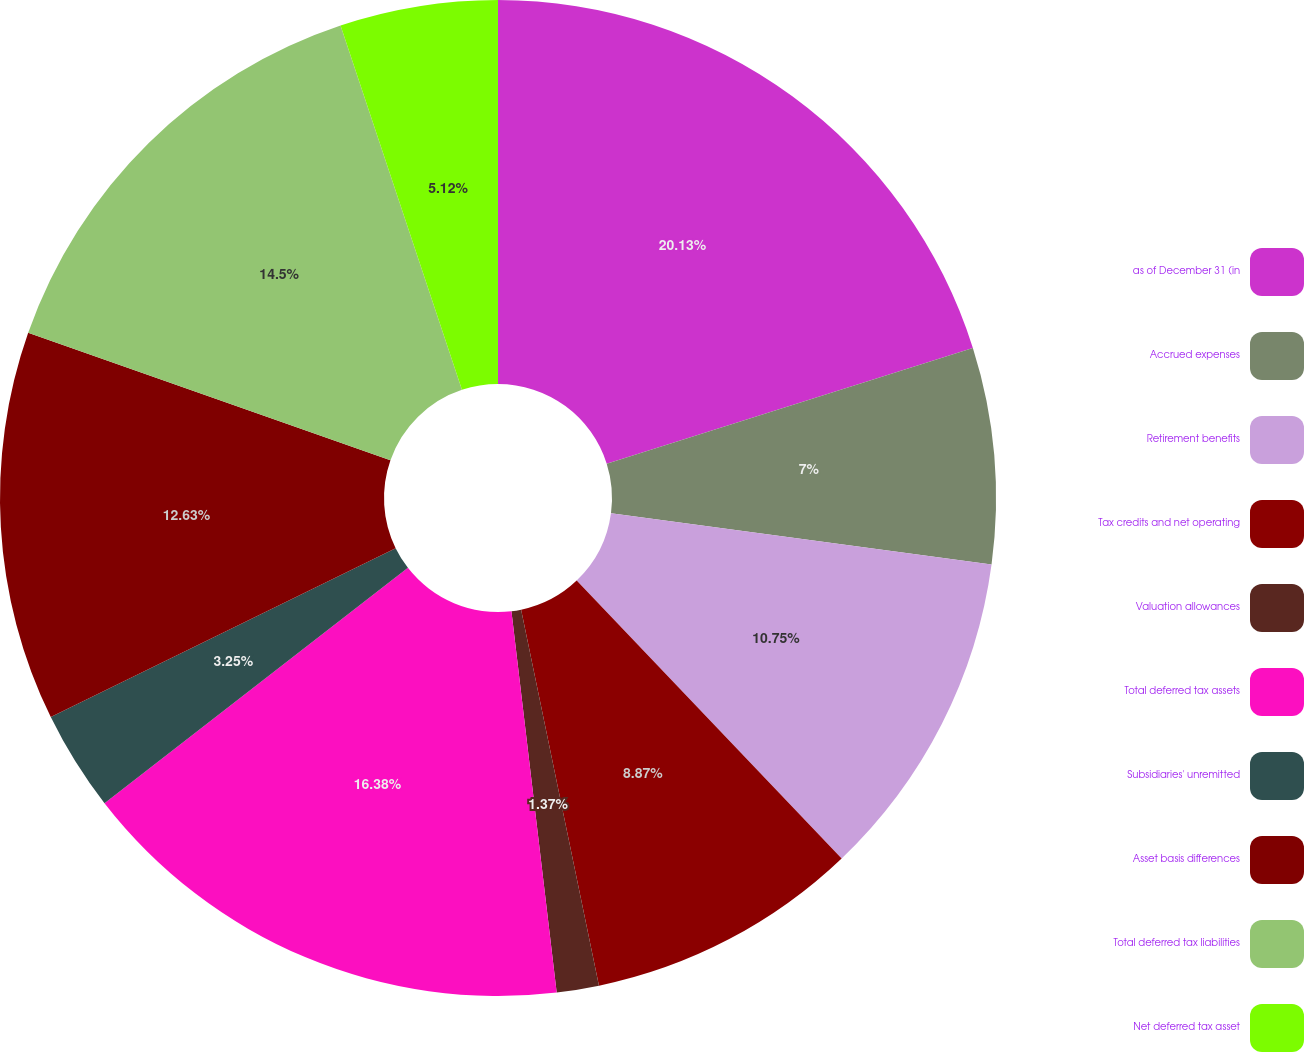Convert chart to OTSL. <chart><loc_0><loc_0><loc_500><loc_500><pie_chart><fcel>as of December 31 (in<fcel>Accrued expenses<fcel>Retirement benefits<fcel>Tax credits and net operating<fcel>Valuation allowances<fcel>Total deferred tax assets<fcel>Subsidiaries' unremitted<fcel>Asset basis differences<fcel>Total deferred tax liabilities<fcel>Net deferred tax asset<nl><fcel>20.13%<fcel>7.0%<fcel>10.75%<fcel>8.87%<fcel>1.37%<fcel>16.38%<fcel>3.25%<fcel>12.63%<fcel>14.5%<fcel>5.12%<nl></chart> 